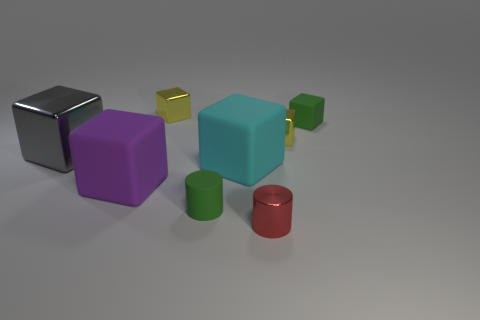Can you tell me about the different shapes and colors in the image? Certainly, the image features a collection of geometric shapes. There are cubes, cylinders, and what appears to be a rectangular prism. They come in a variety of colors - black, purple, cyan, green, red, and yellow, each with a different size, arranged in a seemingly random fashion on a grey surface under soft lighting.  What could be the purpose of this arrangement? This assortment of shapes and colors might be used for several purposes: it could be a simple artistic composition, a setup for a 3D modeling and rendering exercise, or possibly a visual display to teach about geometry and color. The variety in shapes and colors suggests that the creator might be emphasizing contrast and diversity. 